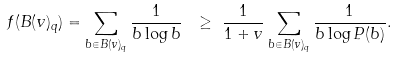Convert formula to latex. <formula><loc_0><loc_0><loc_500><loc_500>f ( B ( v ) _ { q } ) = \sum _ { b \in B ( v ) _ { q } } \frac { 1 } { b \log b } \ & \geq \ \frac { 1 } { 1 + v } \sum _ { b \in B ( v ) _ { q } } \frac { 1 } { b \log P ( b ) } .</formula> 